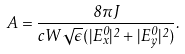<formula> <loc_0><loc_0><loc_500><loc_500>A = \frac { 8 \pi J } { c W \sqrt { \epsilon } ( | E _ { x } ^ { 0 } | ^ { 2 } + | E _ { y } ^ { 0 } | ^ { 2 } ) } .</formula> 